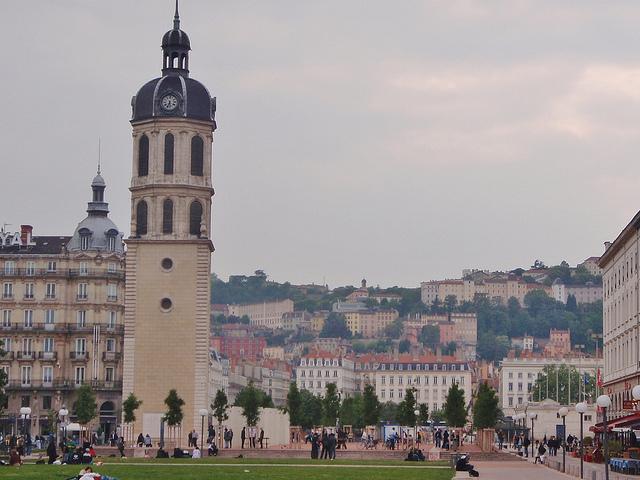How many clocks are here?
Give a very brief answer. 1. Is there a hill in the background?
Short answer required. Yes. How many clock faces are shown?
Keep it brief. 1. What is the towers name?
Quick response, please. Big ben. What's the most likely season?
Quick response, please. Spring. Is this a tourist spot?
Quick response, please. Yes. 